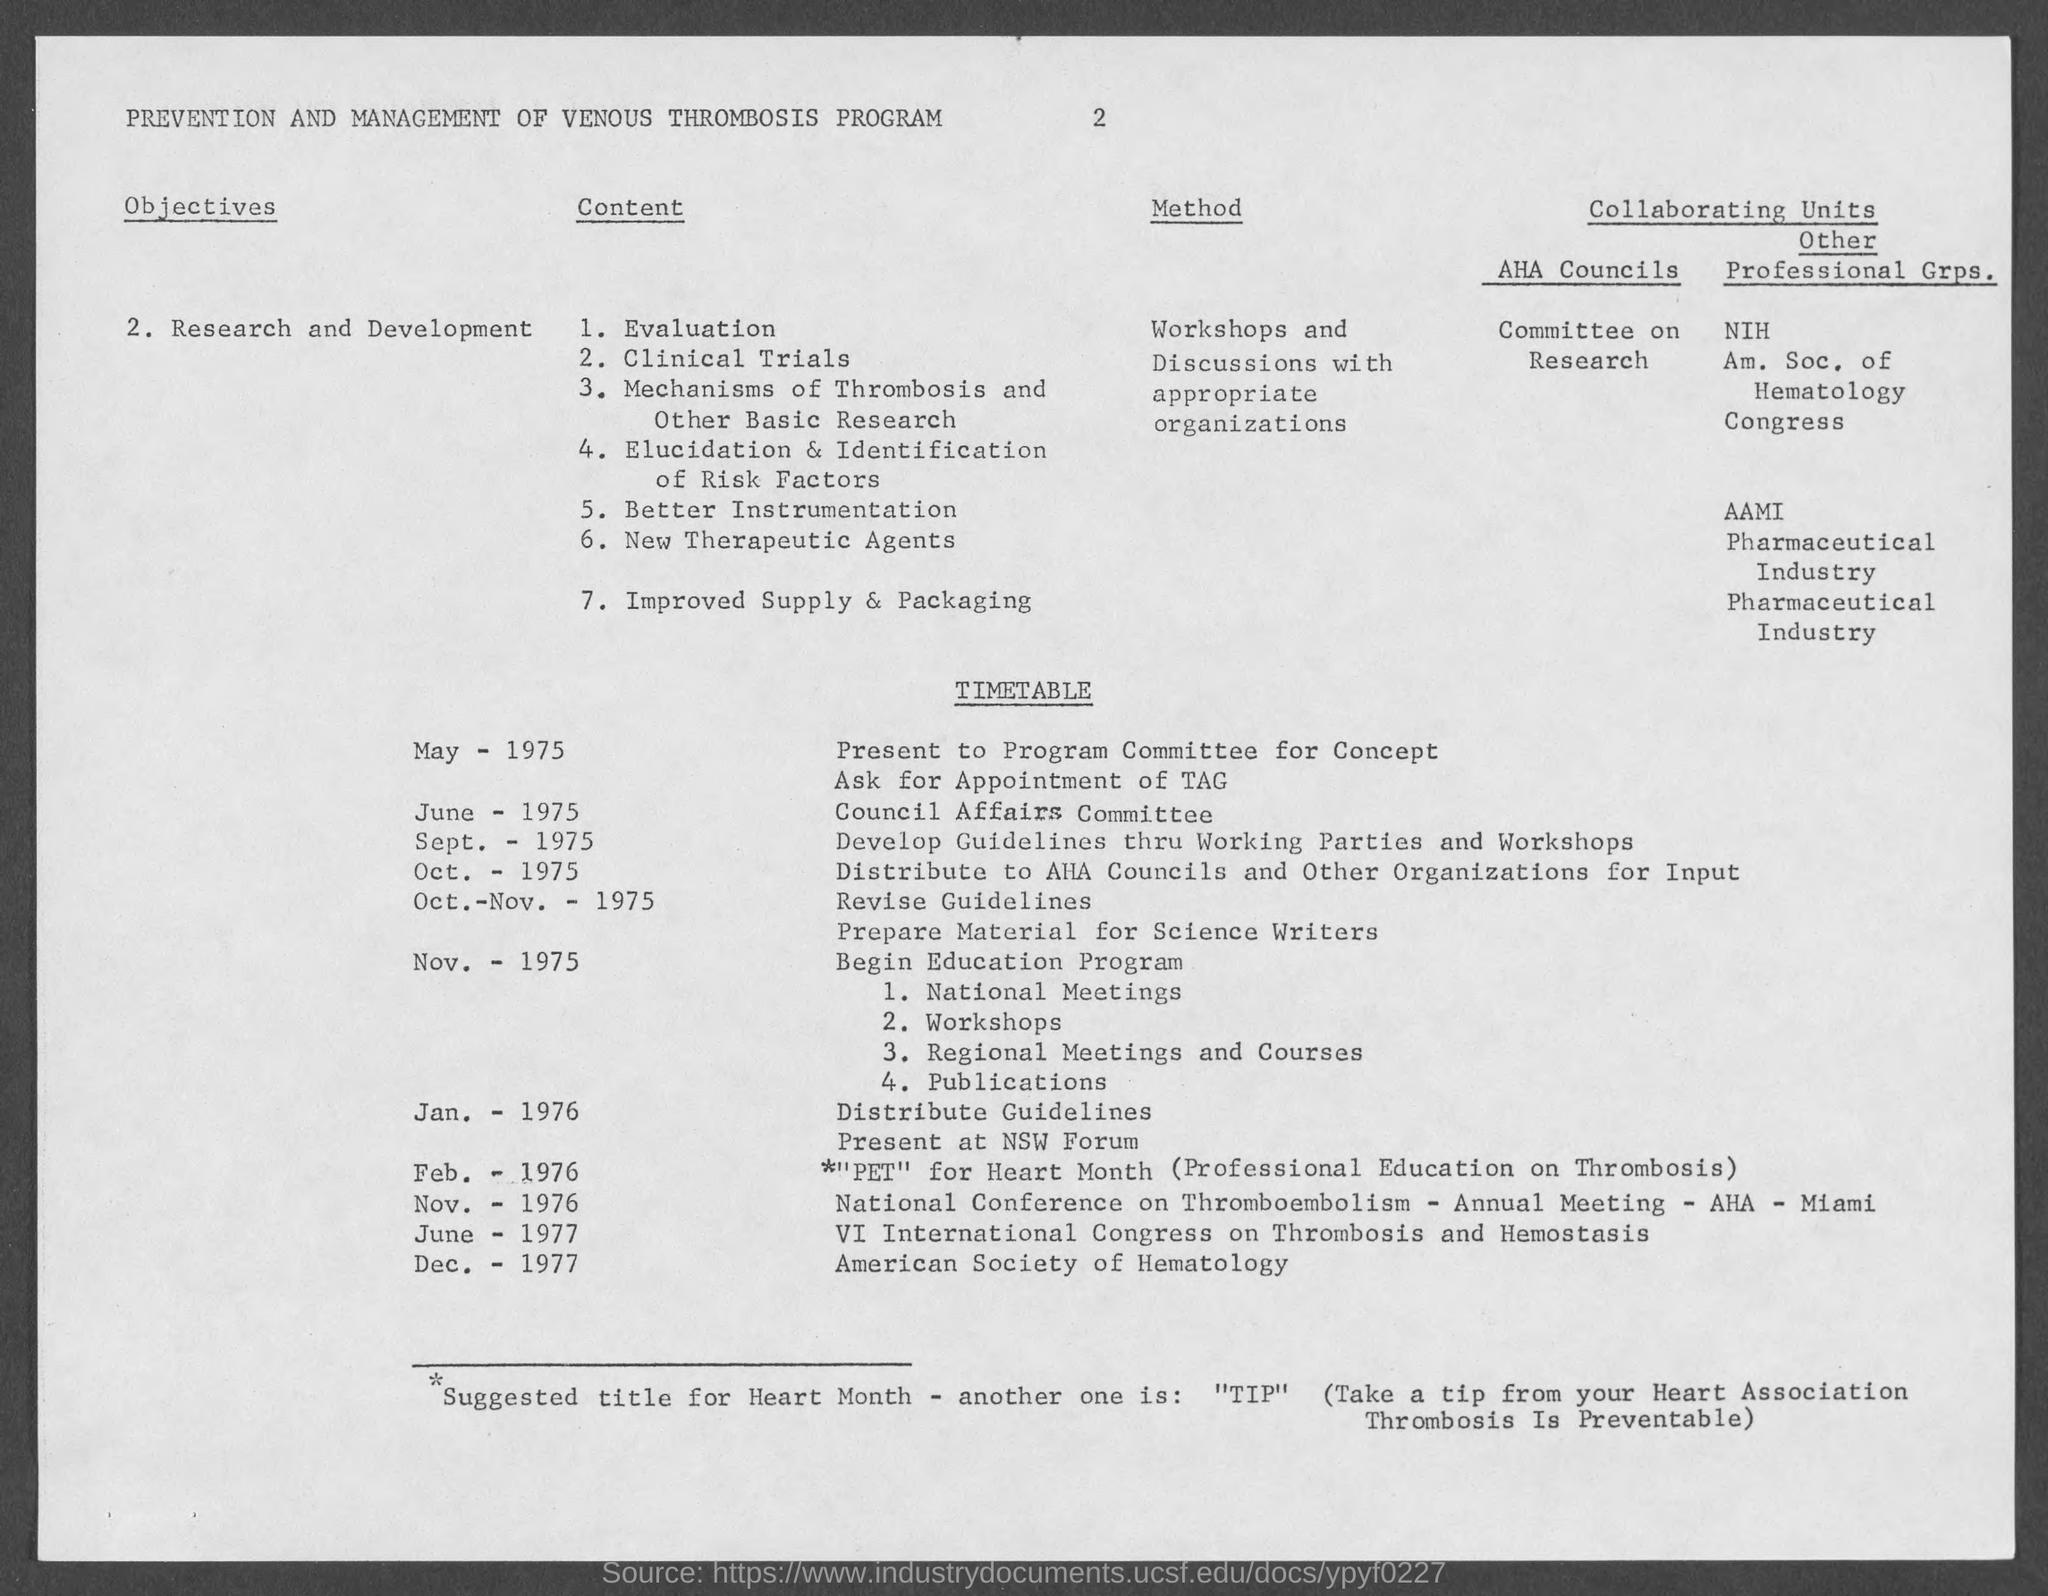Give some essential details in this illustration. I am requesting the page number to be 2.. The title of the document is 'Prevention and Management of Venous Thrombosis Program'. 